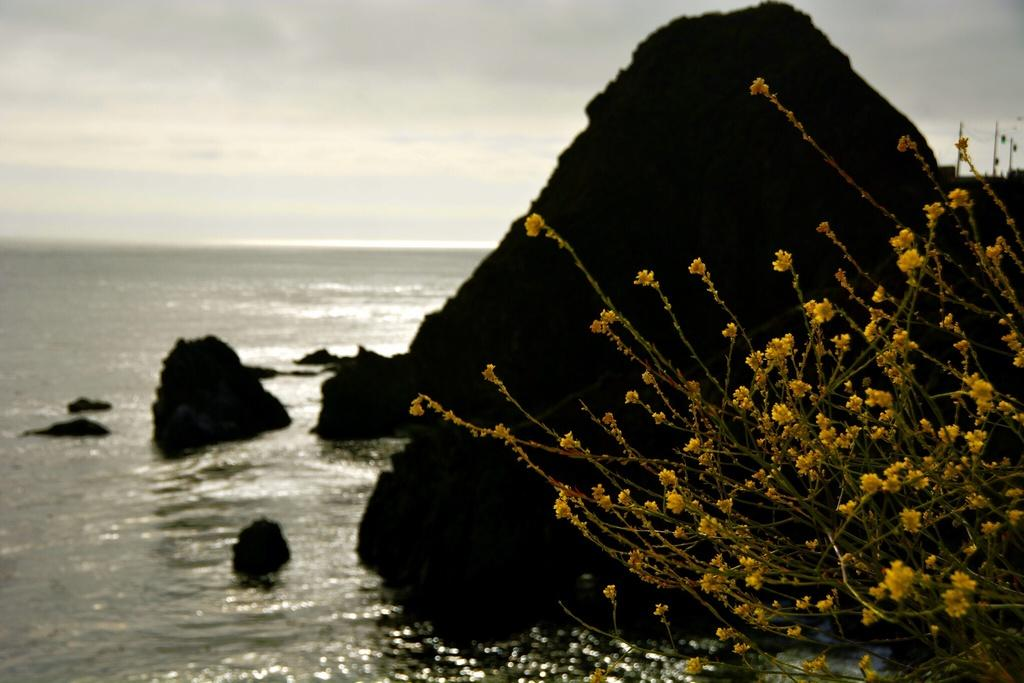What type of plant is visible on the right side of the image? There is a flower plant on the right side of the image. What can be seen on the left side of the image? There is water on the left side of the image. What type of natural material is present on the right side of the image? There are rocks on the right side of the image. What type of cheese is present on the left side of the image? There is no cheese present in the image; it features water on the left side. How many steps are visible in the image? There are no steps visible in the image. 